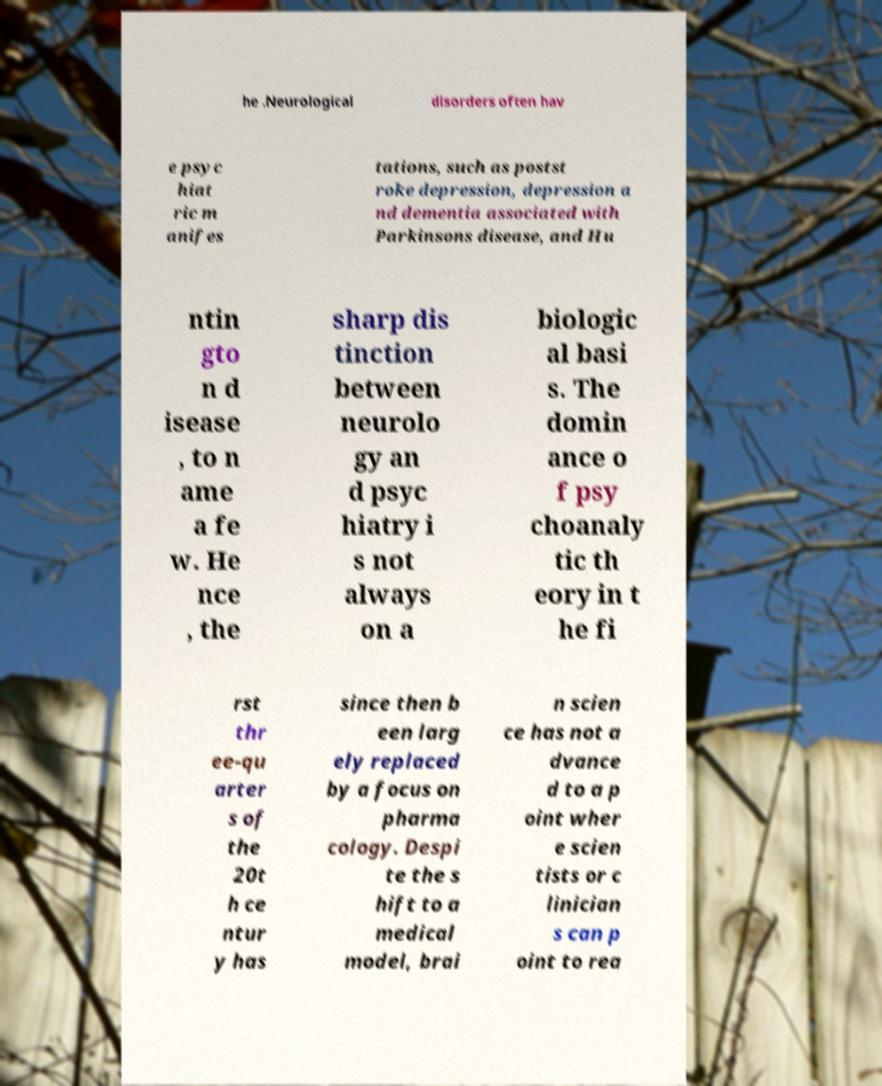There's text embedded in this image that I need extracted. Can you transcribe it verbatim? he .Neurological disorders often hav e psyc hiat ric m anifes tations, such as postst roke depression, depression a nd dementia associated with Parkinsons disease, and Hu ntin gto n d isease , to n ame a fe w. He nce , the sharp dis tinction between neurolo gy an d psyc hiatry i s not always on a biologic al basi s. The domin ance o f psy choanaly tic th eory in t he fi rst thr ee-qu arter s of the 20t h ce ntur y has since then b een larg ely replaced by a focus on pharma cology. Despi te the s hift to a medical model, brai n scien ce has not a dvance d to a p oint wher e scien tists or c linician s can p oint to rea 